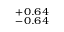Convert formula to latex. <formula><loc_0><loc_0><loc_500><loc_500>^ { + 0 . 6 4 } _ { - 0 . 6 4 }</formula> 